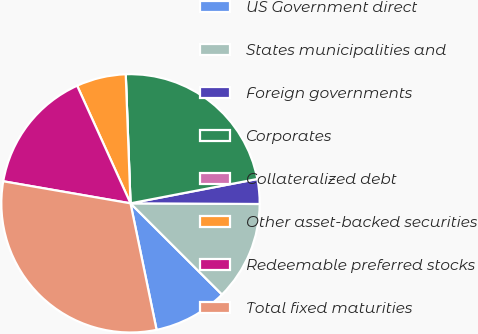Convert chart to OTSL. <chart><loc_0><loc_0><loc_500><loc_500><pie_chart><fcel>US Government direct<fcel>States municipalities and<fcel>Foreign governments<fcel>Corporates<fcel>Collateralized debt<fcel>Other asset-backed securities<fcel>Redeemable preferred stocks<fcel>Total fixed maturities<nl><fcel>9.29%<fcel>12.39%<fcel>3.1%<fcel>22.57%<fcel>0.0%<fcel>6.19%<fcel>15.49%<fcel>30.97%<nl></chart> 